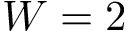<formula> <loc_0><loc_0><loc_500><loc_500>W = 2</formula> 